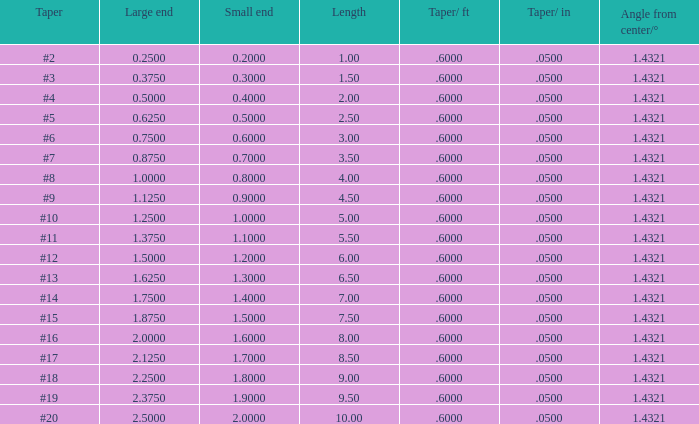7000000000000001, and a taper of #19, and a big tip larger than None. 